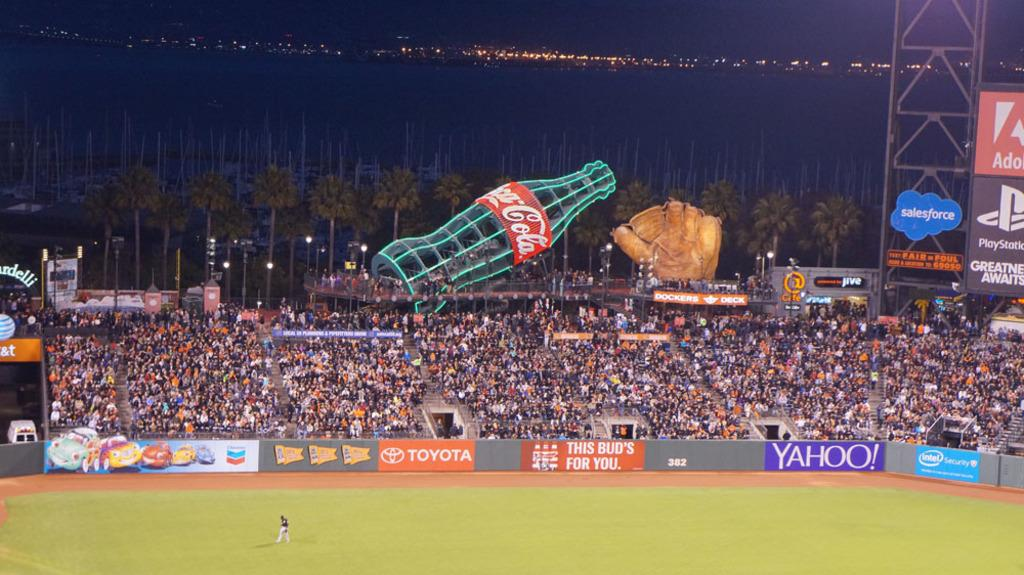<image>
Share a concise interpretation of the image provided. a high view of a stadium with adds for yahoo, toyota, and coca-cola 